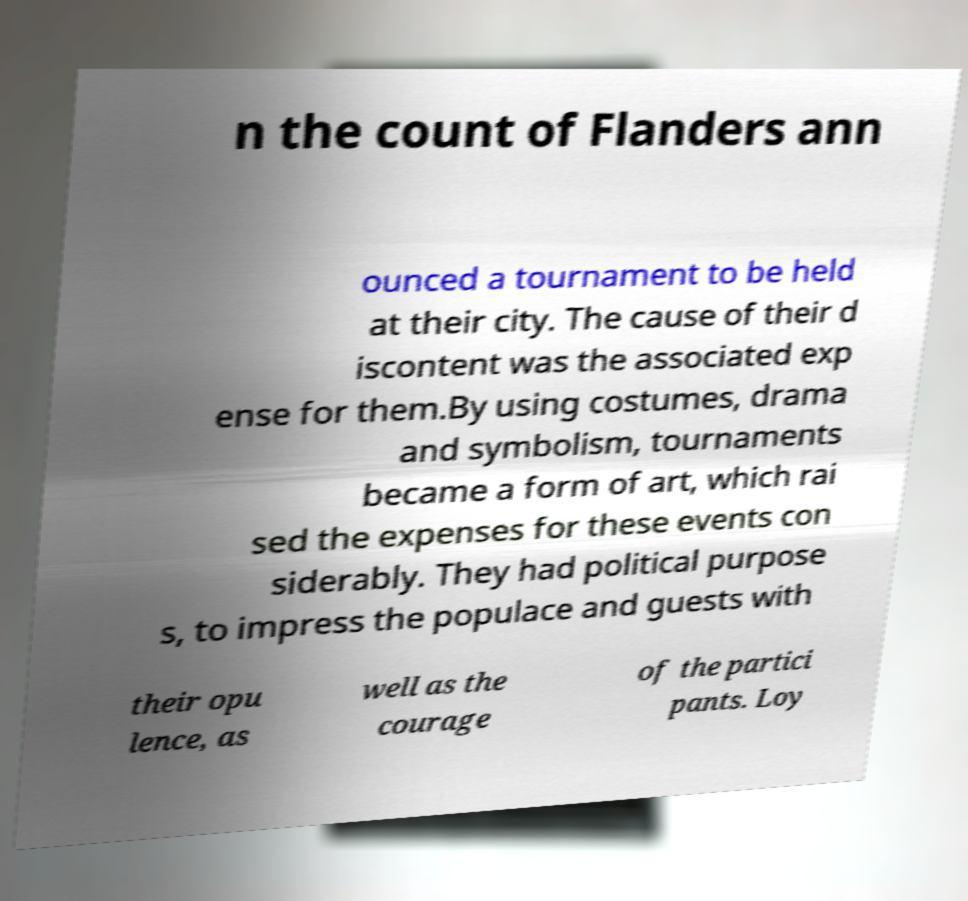Could you extract and type out the text from this image? n the count of Flanders ann ounced a tournament to be held at their city. The cause of their d iscontent was the associated exp ense for them.By using costumes, drama and symbolism, tournaments became a form of art, which rai sed the expenses for these events con siderably. They had political purpose s, to impress the populace and guests with their opu lence, as well as the courage of the partici pants. Loy 